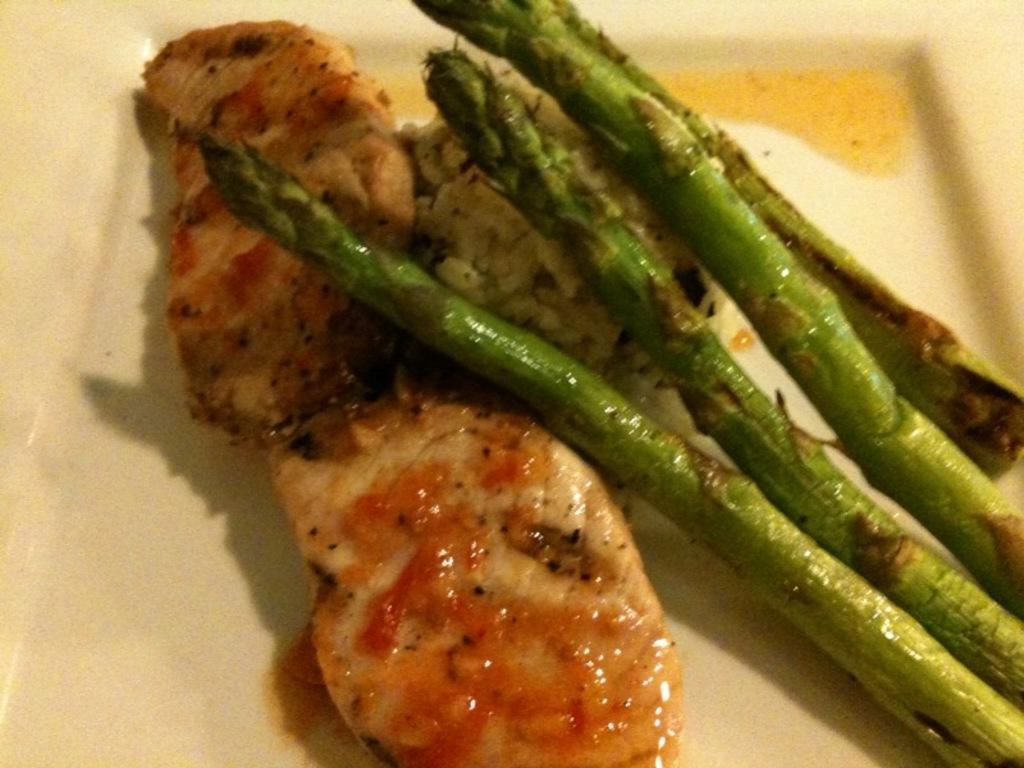Could you give a brief overview of what you see in this image? In this image we can see a food items placed on a plate. 